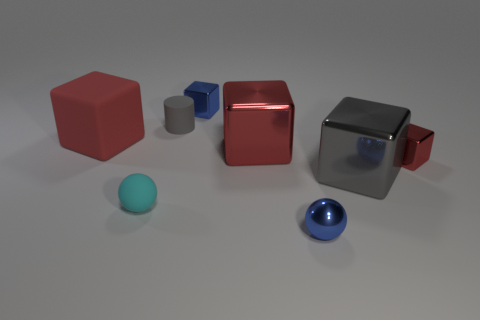Are there any large gray rubber things? Yes, there is a large gray cube that may appear to be made of rubber or a matte plastic based on its texture and reflections. 